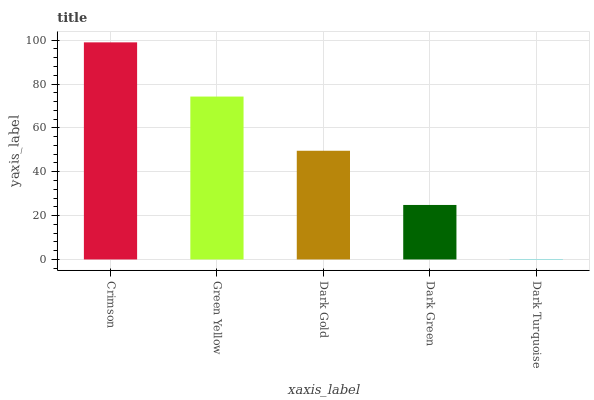Is Dark Turquoise the minimum?
Answer yes or no. Yes. Is Crimson the maximum?
Answer yes or no. Yes. Is Green Yellow the minimum?
Answer yes or no. No. Is Green Yellow the maximum?
Answer yes or no. No. Is Crimson greater than Green Yellow?
Answer yes or no. Yes. Is Green Yellow less than Crimson?
Answer yes or no. Yes. Is Green Yellow greater than Crimson?
Answer yes or no. No. Is Crimson less than Green Yellow?
Answer yes or no. No. Is Dark Gold the high median?
Answer yes or no. Yes. Is Dark Gold the low median?
Answer yes or no. Yes. Is Green Yellow the high median?
Answer yes or no. No. Is Dark Turquoise the low median?
Answer yes or no. No. 